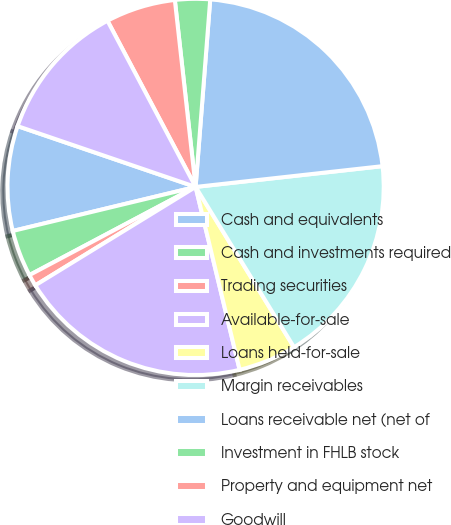<chart> <loc_0><loc_0><loc_500><loc_500><pie_chart><fcel>Cash and equivalents<fcel>Cash and investments required<fcel>Trading securities<fcel>Available-for-sale<fcel>Loans held-for-sale<fcel>Margin receivables<fcel>Loans receivable net (net of<fcel>Investment in FHLB stock<fcel>Property and equipment net<fcel>Goodwill<nl><fcel>9.0%<fcel>4.0%<fcel>1.0%<fcel>20.0%<fcel>5.0%<fcel>18.0%<fcel>22.0%<fcel>3.0%<fcel>6.0%<fcel>12.0%<nl></chart> 